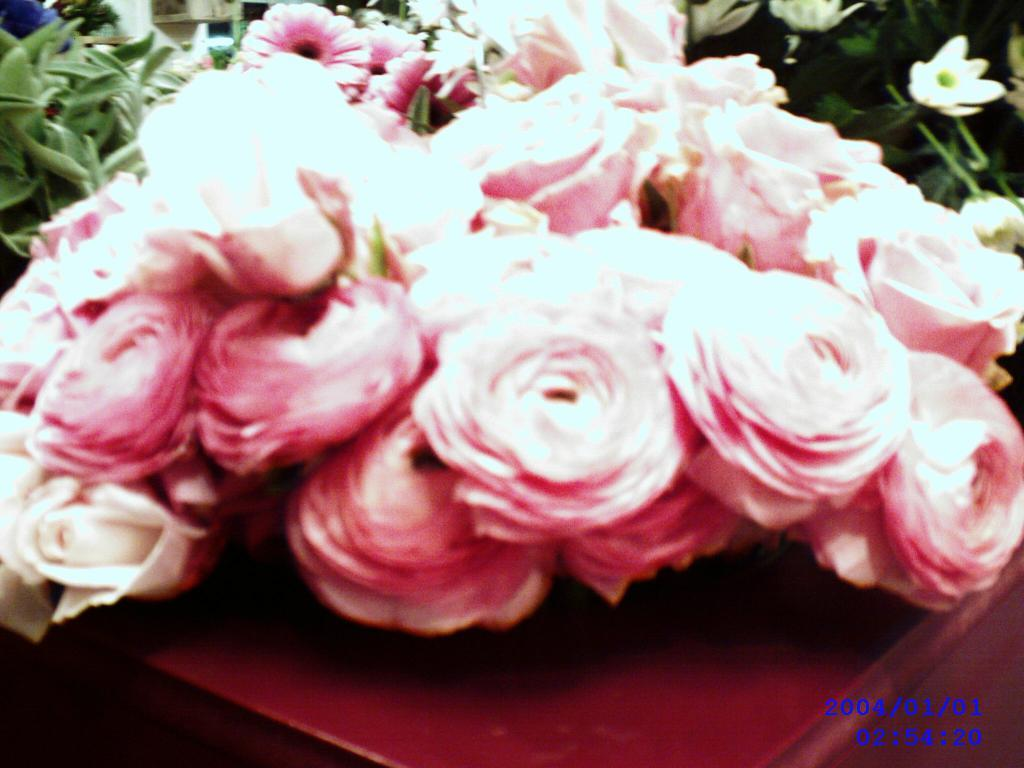What type of plants are visible in the image? There are flowers in the image. What else can be seen alongside the flowers? There are green leaves on both sides of the flowers. Is there any text or marking in the image? Yes, there is a watermark in the bottom right side of the image. What type of needle is used to create the expansion in the image? There is no expansion or needle present in the image; it features flowers and green leaves. 